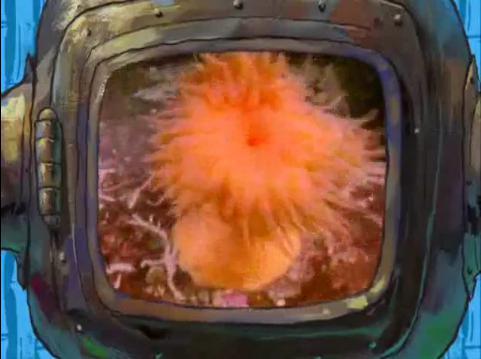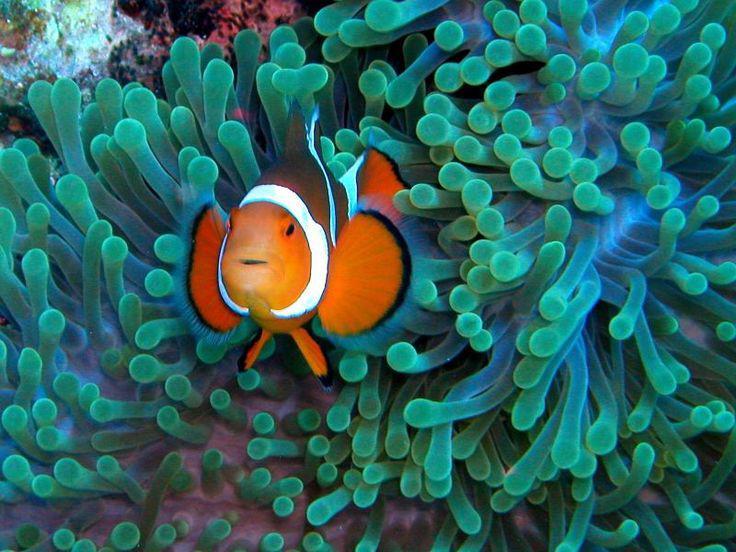The first image is the image on the left, the second image is the image on the right. Given the left and right images, does the statement "The right image features at least one clown fish swimming in front of anemone tendrils, and the left image includes at least one anemone with tapering tendrils and an orange stalk." hold true? Answer yes or no. Yes. The first image is the image on the left, the second image is the image on the right. Examine the images to the left and right. Is the description "The right image contains at least two clown fish." accurate? Answer yes or no. No. 